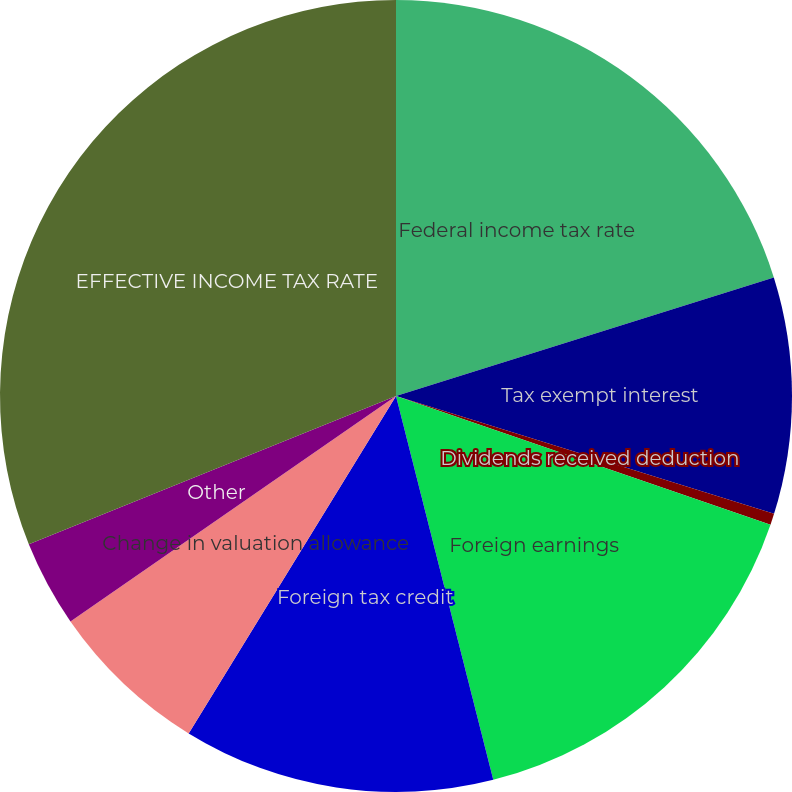<chart> <loc_0><loc_0><loc_500><loc_500><pie_chart><fcel>Federal income tax rate<fcel>Tax exempt interest<fcel>Dividends received deduction<fcel>Foreign earnings<fcel>Foreign tax credit<fcel>Change in valuation allowance<fcel>Other<fcel>EFFECTIVE INCOME TAX RATE<nl><fcel>20.16%<fcel>9.65%<fcel>0.46%<fcel>15.78%<fcel>12.72%<fcel>6.59%<fcel>3.53%<fcel>31.11%<nl></chart> 